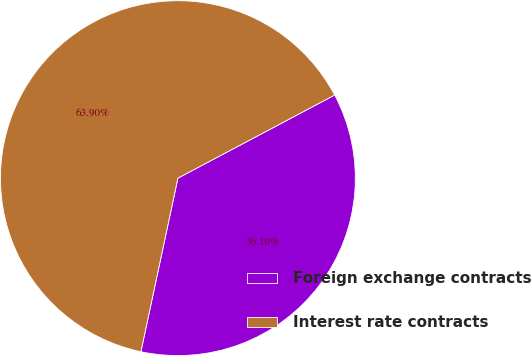Convert chart. <chart><loc_0><loc_0><loc_500><loc_500><pie_chart><fcel>Foreign exchange contracts<fcel>Interest rate contracts<nl><fcel>36.1%<fcel>63.9%<nl></chart> 